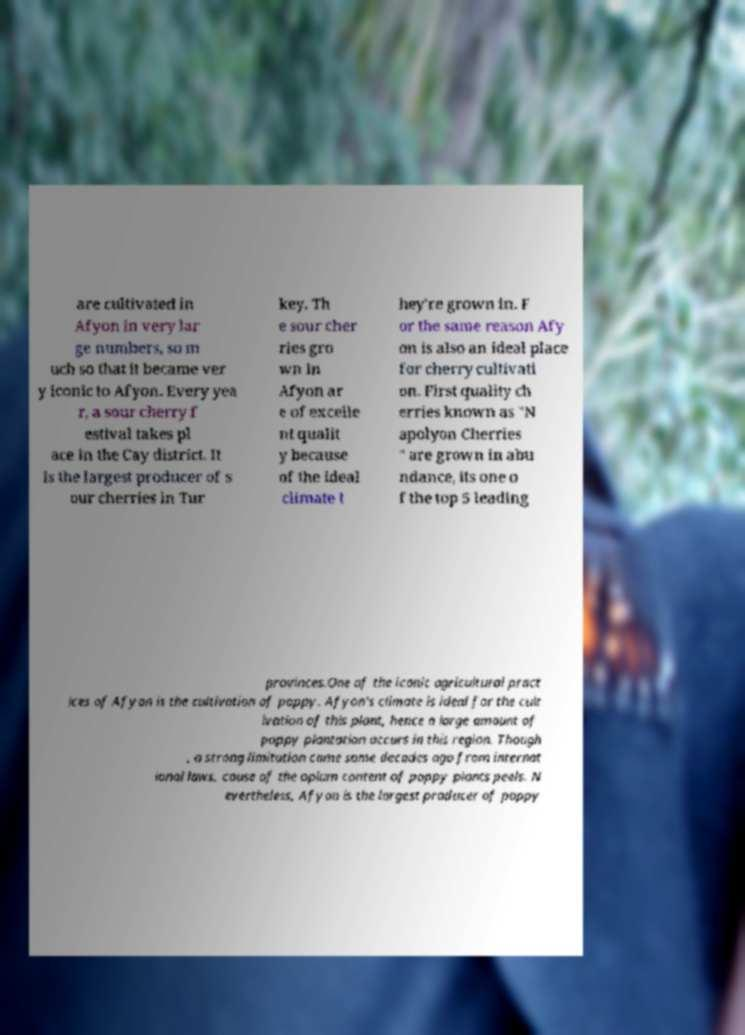Please read and relay the text visible in this image. What does it say? are cultivated in Afyon in very lar ge numbers, so m uch so that it became ver y iconic to Afyon. Every yea r, a sour cherry f estival takes pl ace in the Cay district. It is the largest producer of s our cherries in Tur key. Th e sour cher ries gro wn in Afyon ar e of excelle nt qualit y because of the ideal climate t hey're grown in. F or the same reason Afy on is also an ideal place for cherry cultivati on. First quality ch erries known as "N apolyon Cherries " are grown in abu ndance, its one o f the top 5 leading provinces.One of the iconic agricultural pract ices of Afyon is the cultivation of poppy. Afyon's climate is ideal for the cult ivation of this plant, hence a large amount of poppy plantation occurs in this region. Though , a strong limitation came some decades ago from internat ional laws, cause of the opium content of poppy plants peels. N evertheless, Afyon is the largest producer of poppy 